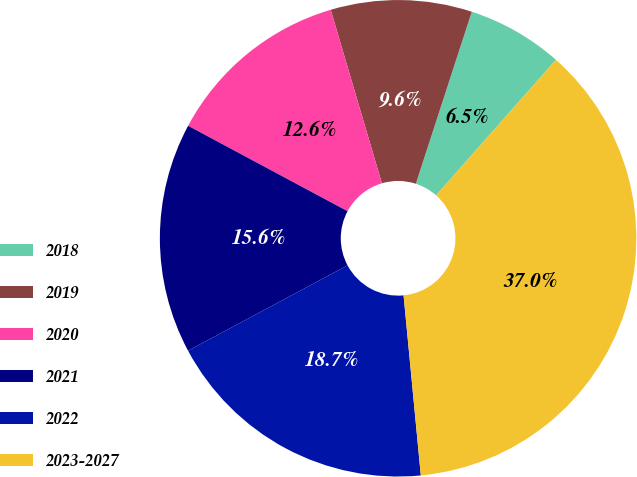Convert chart. <chart><loc_0><loc_0><loc_500><loc_500><pie_chart><fcel>2018<fcel>2019<fcel>2020<fcel>2021<fcel>2022<fcel>2023-2027<nl><fcel>6.52%<fcel>9.57%<fcel>12.61%<fcel>15.65%<fcel>18.7%<fcel>36.96%<nl></chart> 